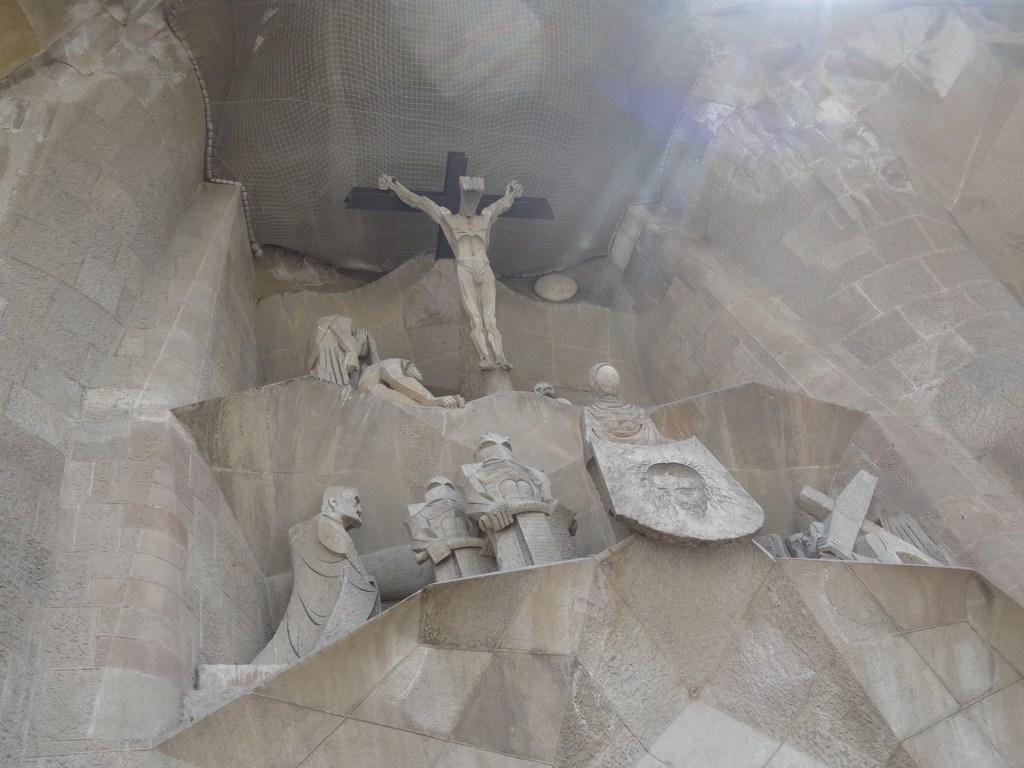Describe this image in one or two sentences. In this image in the middle, there are statues. At the top there is net. In the middle there is wall. 